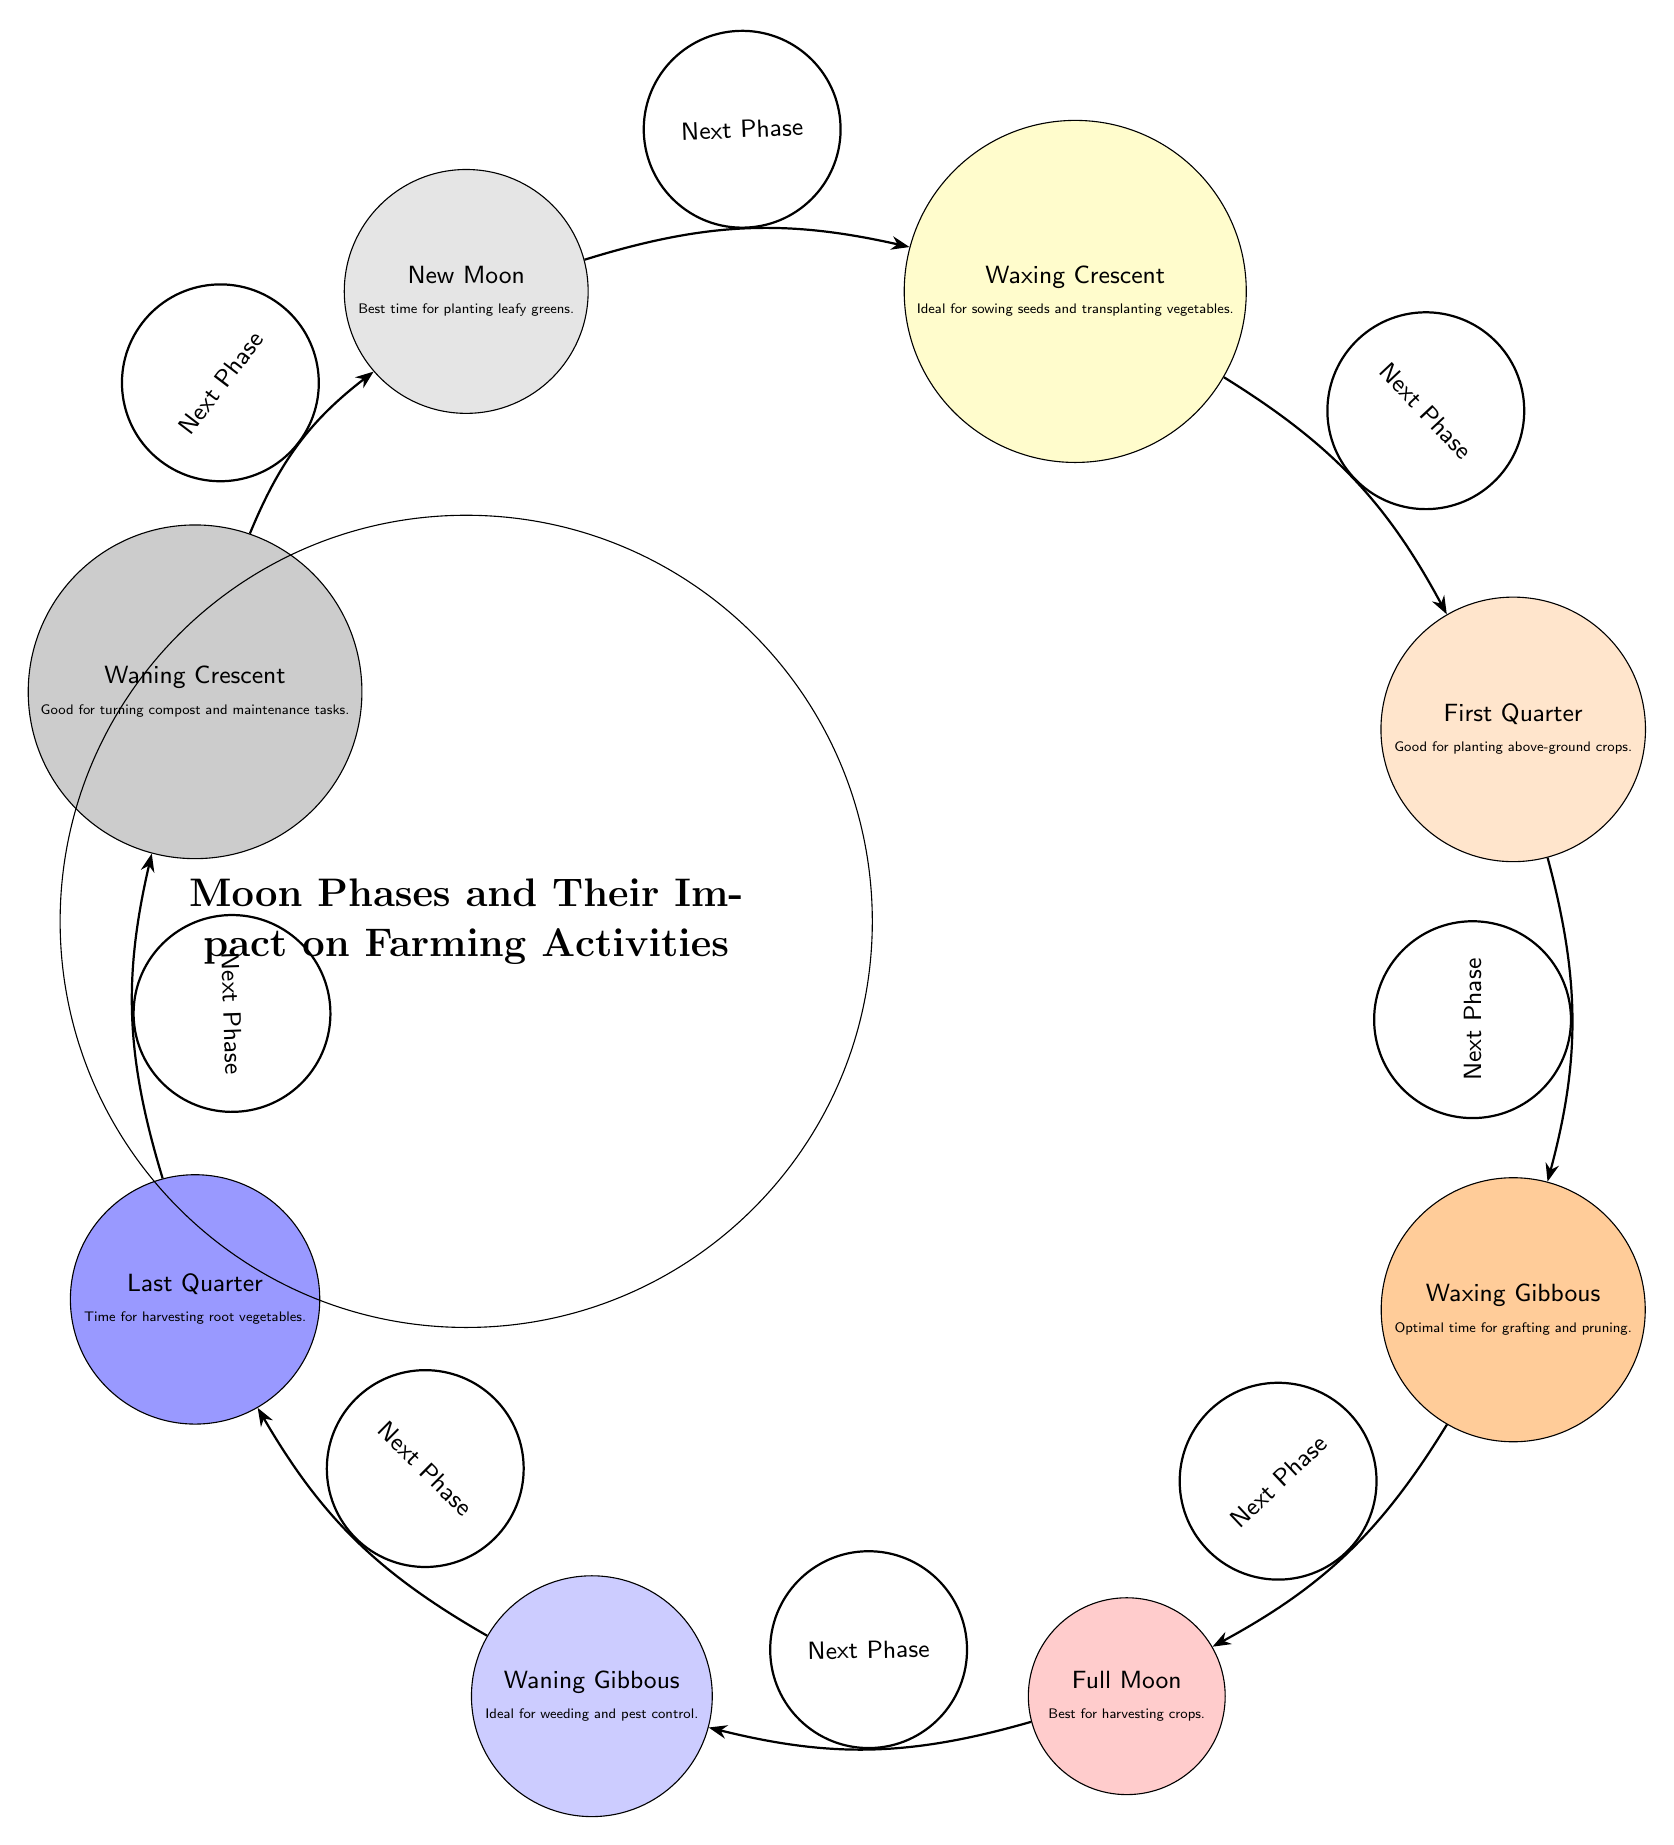What is the first phase of the Moon in the diagram? The diagram presents the phases in order, starting from New Moon, which is described at the top left of the diagram.
Answer: New Moon Which phase of the Moon is best for harvesting crops? According to the diagram, the Full Moon is specifically noted as the best time for harvesting crops, positioned at the bottom of the diagram.
Answer: Full Moon How many phases of the Moon are illustrated in the diagram? The diagram features eight distinct phases of the Moon, including New Moon and reaching back to New Moon again, forming a complete cycle.
Answer: 8 What is the phase following the Waning Gibbous? The diagram clearly shows that after Waning Gibbous, the next phase is Last Quarter. This can be determined by tracing the arrow connection from Waning Gibbous.
Answer: Last Quarter During which phase is it ideal for weeding and pest control? The diagram states that the Waning Gibbous phase is ideal for weeding and pest control, which can be found to the left side in the lower half of the diagram.
Answer: Waning Gibbous What activity is suggested for the Waxing Gibbous phase? The diagram indicates that Waxing Gibbous is the optimal time for grafting and pruning, which is directly noted in the information provided within that phase.
Answer: Grafting and pruning What does the arrow between First Quarter and Waxing Gibbous indicate? The arrow signifies the progression from one phase to the next, indicating that Waxing Gibbous follows First Quarter, denoting a cycle of lunar phases.
Answer: Next Phase Which phase is recommended for turning compost and maintenance tasks? The diagram advises that the Waning Crescent phase is suitable for turning compost and maintenance tasks, which appears in the upper half and is the final phase before returning to New Moon.
Answer: Waning Crescent 